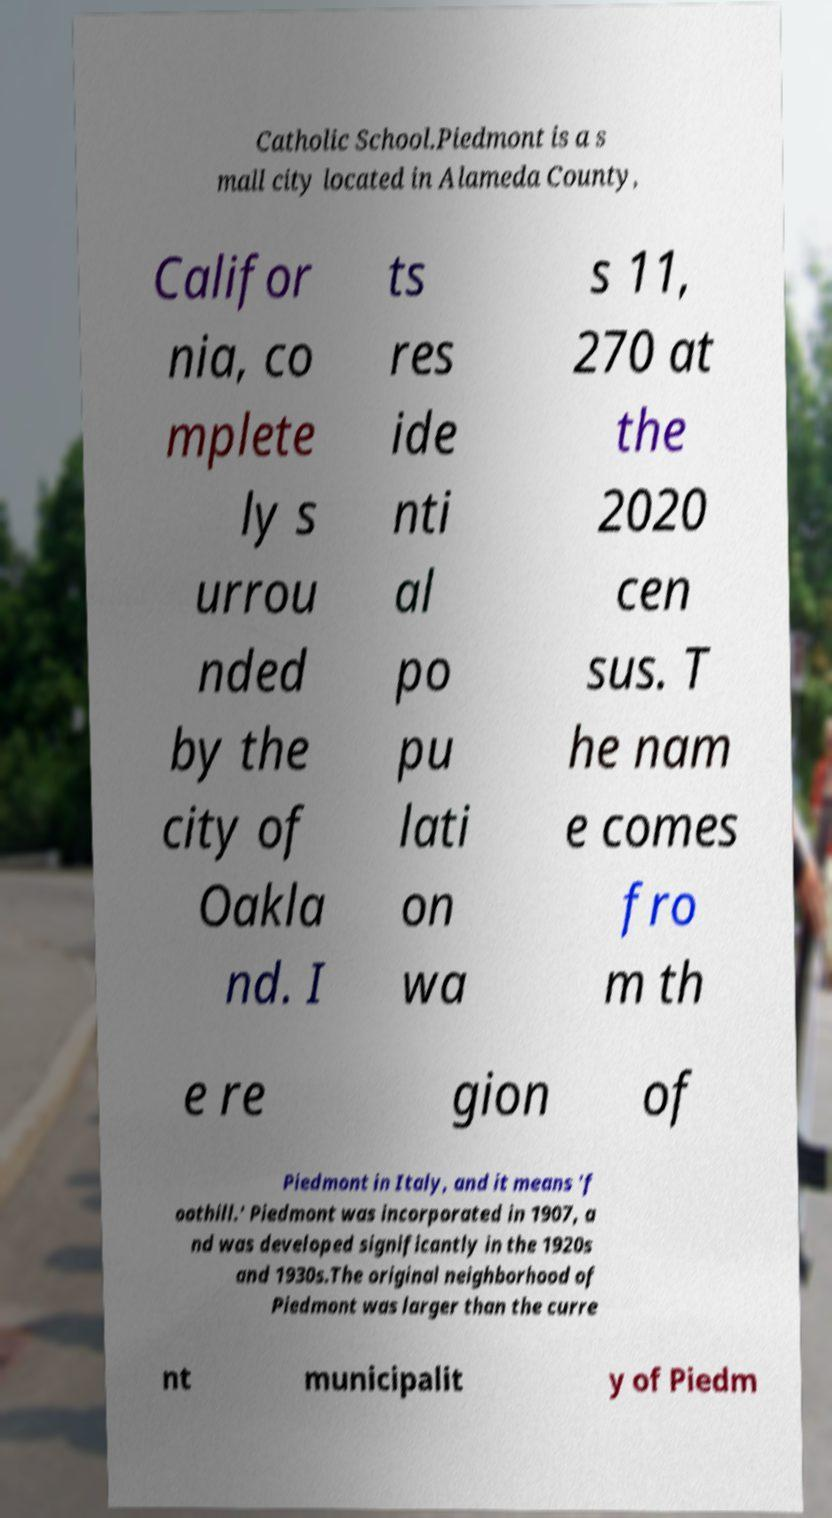Please identify and transcribe the text found in this image. Catholic School.Piedmont is a s mall city located in Alameda County, Califor nia, co mplete ly s urrou nded by the city of Oakla nd. I ts res ide nti al po pu lati on wa s 11, 270 at the 2020 cen sus. T he nam e comes fro m th e re gion of Piedmont in Italy, and it means 'f oothill.' Piedmont was incorporated in 1907, a nd was developed significantly in the 1920s and 1930s.The original neighborhood of Piedmont was larger than the curre nt municipalit y of Piedm 